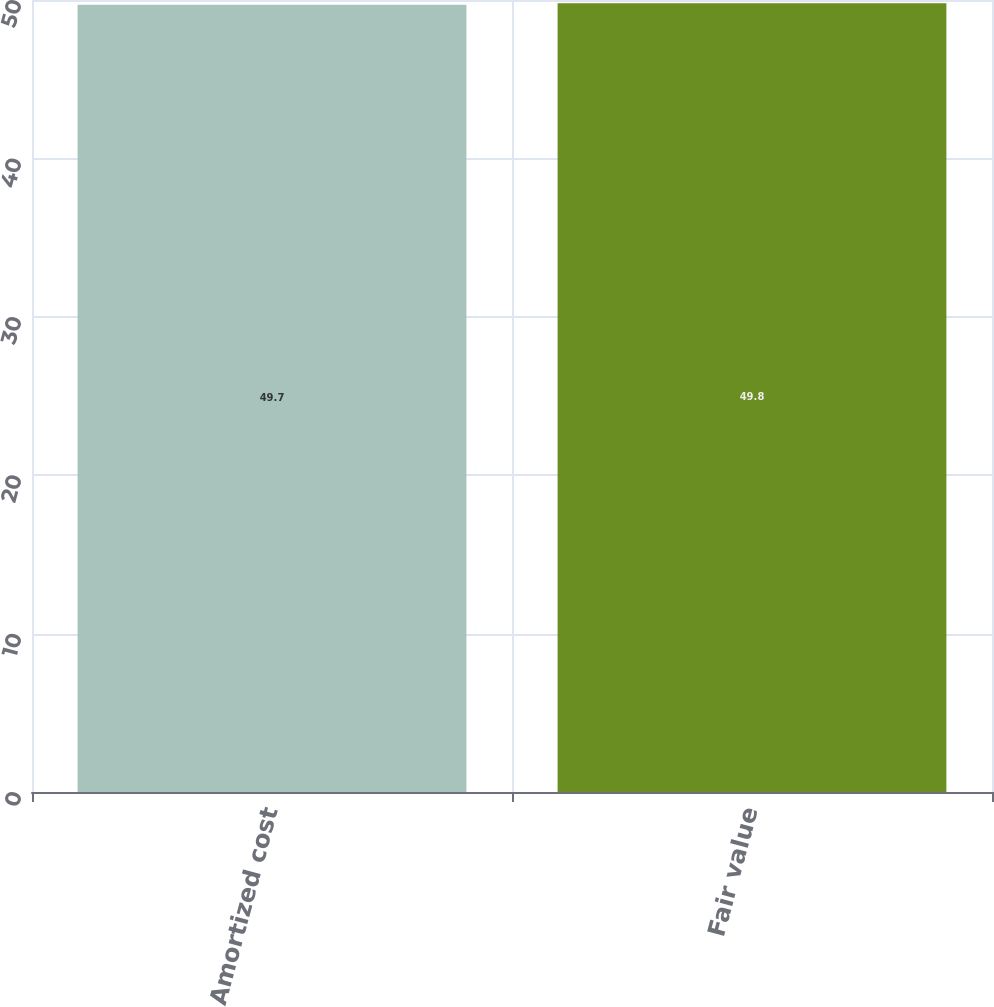Convert chart. <chart><loc_0><loc_0><loc_500><loc_500><bar_chart><fcel>Amortized cost<fcel>Fair value<nl><fcel>49.7<fcel>49.8<nl></chart> 